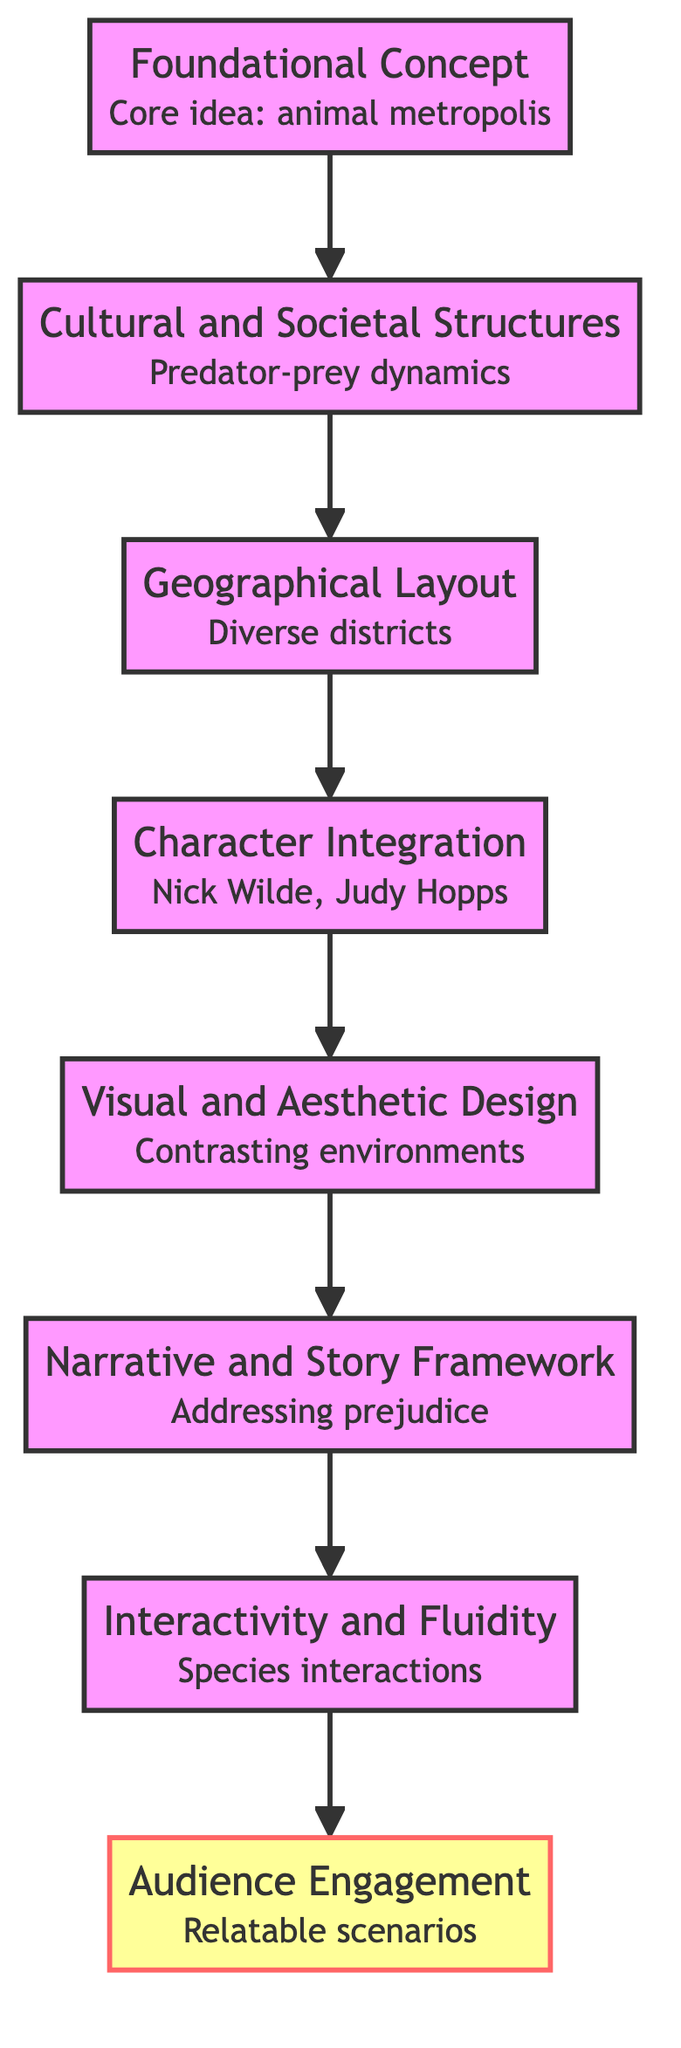What is the first stage in world-building? The first stage is specified as "Foundational Concept." This is indicated by the fact that it is the top node in the flow and has an arrow pointing down to the next stage, showing that it initiates the world-building process.
Answer: Foundational Concept How many stages are in the world-building process? The flow chart outlines a total of eight stages from top to bottom. This can be counted by identifying all the nodes present, including the audience engagement stage at the end.
Answer: 8 What is the final stage in the diagram? The last node in the flow chart is "Audience Engagement." This is seen as it is the bottom-most node, signifying the culmination of the world-building process.
Answer: Audience Engagement What role does "Character Integration" play in world-building? "Character Integration" is the fourth stage in the flow, indicating that it comes after "Geographical Layout" and before "Visual and Aesthetic Design." Its role is vital as it involves creating characters that interact within the defined world, showcasing how they embody the world’s societal fabric.
Answer: Creating characters What is the relationship between "Visual and Aesthetic Design" and "Narrative and Story Framework"? "Visual and Aesthetic Design" directly precedes "Narrative and Story Framework" in the flow chart. This order implies that the visual elements support and reinforce the storytelling aspects of the world, showcasing how the aesthetics can influence or complement the plot development.
Answer: Sequential support Which stage addresses societal dynamics? The stage that addresses societal dynamics is "Cultural and Societal Structures," as it focuses on defining social norms and values within the animated world. In the context of Zootopia, this would include the predator-prey dynamics presented in the film.
Answer: Cultural and Societal Structures What is emphasized in "Interactivity and Fluidity"? "Interactivity and Fluidity" emphasizes the seamless interaction and evolution of different elements within the animated world. This stage indicates how species interact with one another and the dynamic nature of their relationships within the setting.
Answer: Seamless interaction How does the diagram represent flow direction? The diagram employs arrows pointing upwards from each node to the next, clearly indicating a progression from foundational concepts to audience engagement. This structure helps to visualize the hierarchical and sequential nature of the world-building stages.
Answer: Upward arrows 